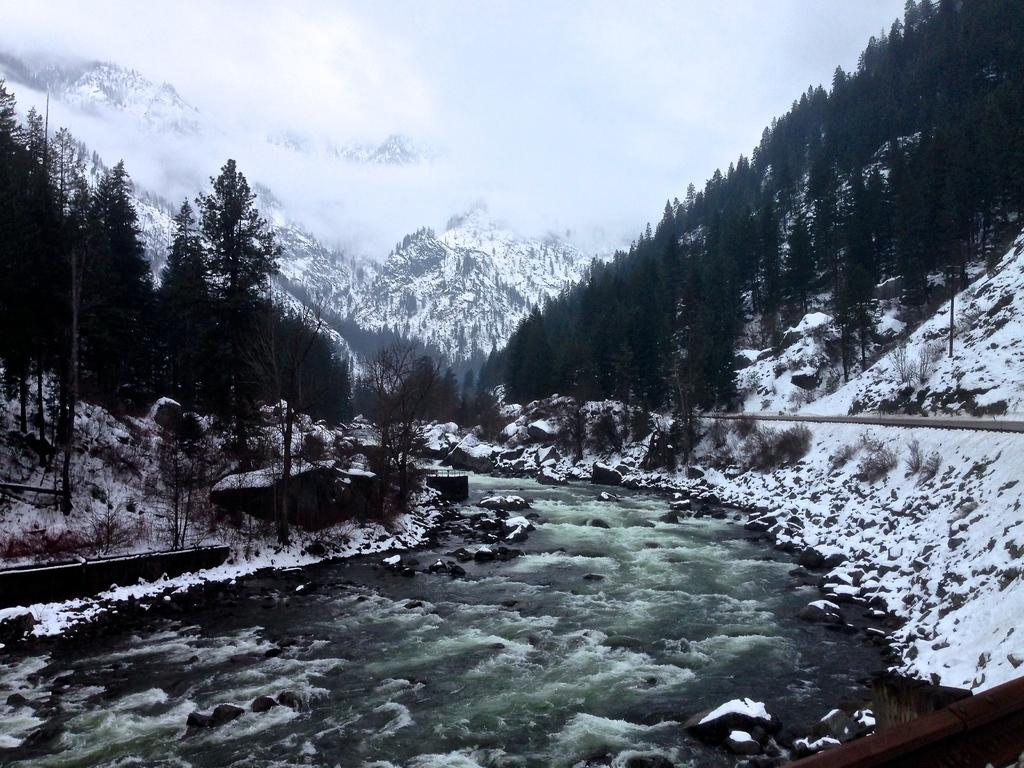What type of natural feature is present in the image? There is a river in the image. What surrounds the river? Tall trees are present on both sides of the river. What can be seen in the background of the image? There is a mountain with snow in the background of the image. What type of hair can be seen on the mountain in the image? There is no hair present in the image; it features a river, tall trees, and a mountain with snow. 